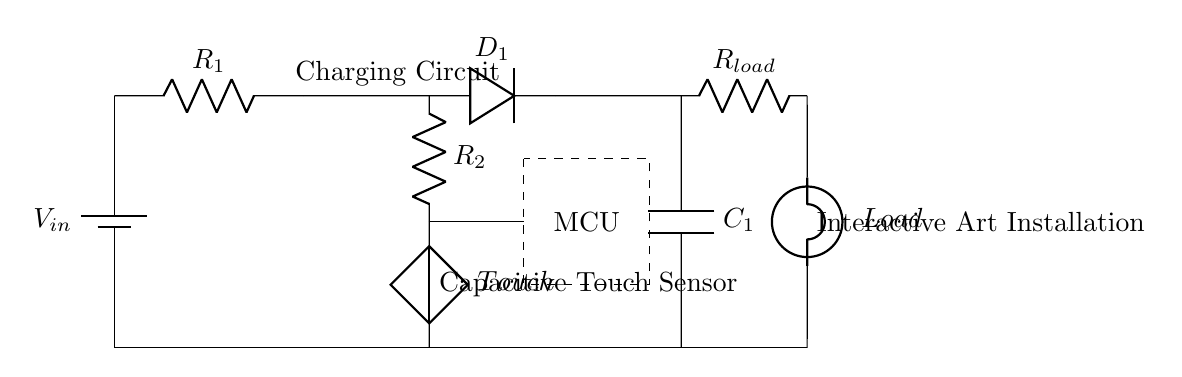What is the input voltage of the circuit? The circuit has a battery labeled as V_in connected to the input, indicating that it's the source voltage.
Answer: V_in What type of components are used in the charging circuit? The charging circuit consists of a resistor, a diode, and a capacitor, as shown in the labeled components.
Answer: Resistor, diode, capacitor How is the touch mechanism connected in the circuit? The touch mechanism is represented by a capacitive touch sensor connected to a resistor and a microcontroller, allowing for user interaction.
Answer: Through a resistor to the microcontroller What is the purpose of the diode in this circuit? The diode is used to allow current to flow in one direction, preventing reverse current that could discharge the capacitor unexpectedly.
Answer: To prevent reverse current What happens to the load when the touch sensor is activated? When the touch sensor is activated, it sends a signal to the microcontroller, which then activates the load connected in the circuit.
Answer: The load turns on What is the role of the microcontroller in this circuit? The microcontroller processes the input from the touch sensor and controls the operation of the load based on that input.
Answer: To control the load based on touch input What connection allows the charge to return to the source in this circuit? The capacitor is connected in parallel to the rest of the circuit, allowing it to discharge back into the input through the return connections.
Answer: Through the capacitor connections 